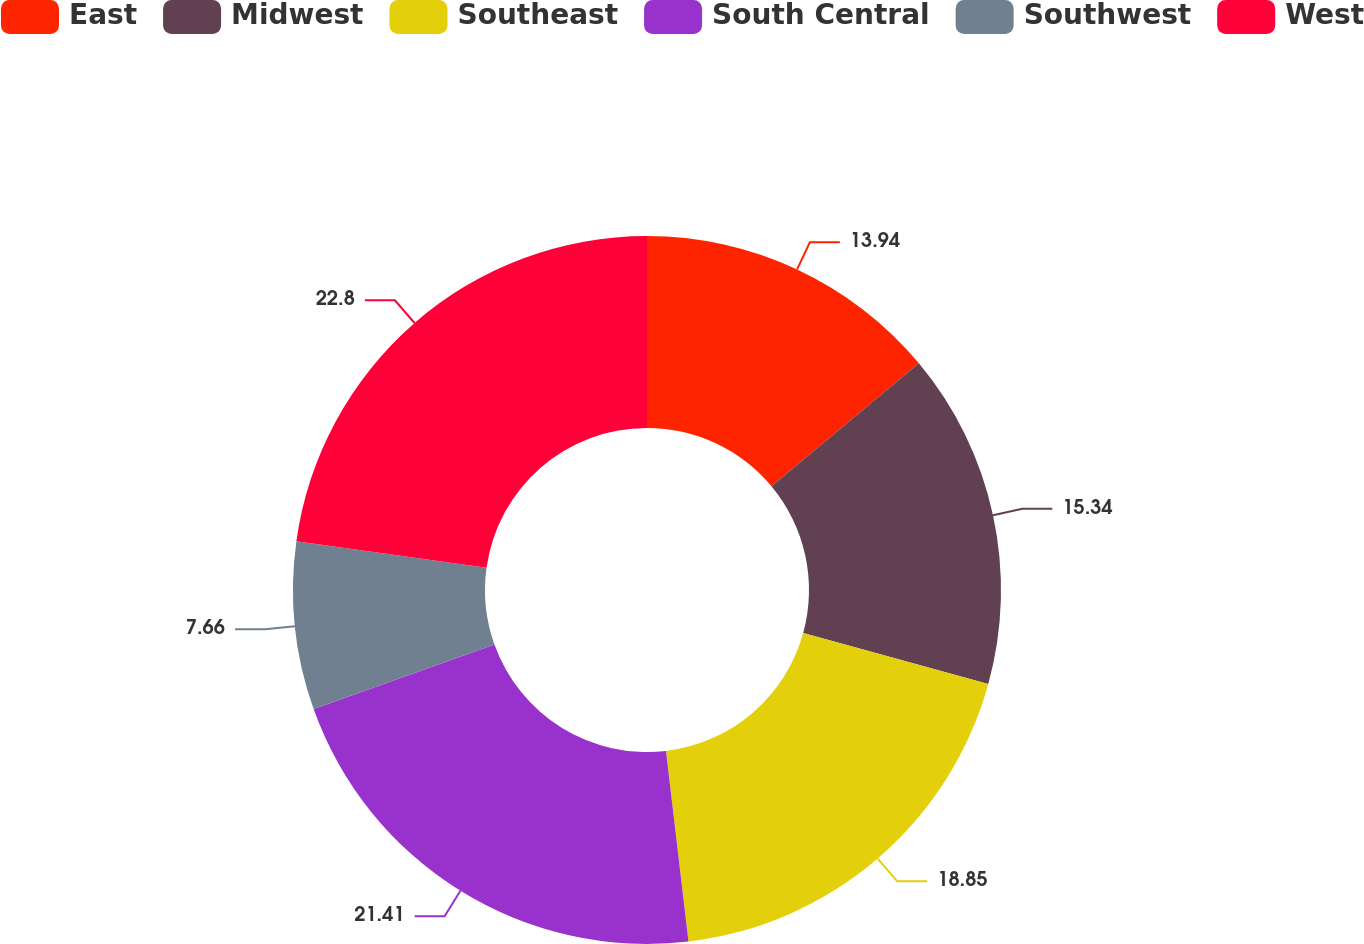Convert chart to OTSL. <chart><loc_0><loc_0><loc_500><loc_500><pie_chart><fcel>East<fcel>Midwest<fcel>Southeast<fcel>South Central<fcel>Southwest<fcel>West<nl><fcel>13.94%<fcel>15.34%<fcel>18.85%<fcel>21.41%<fcel>7.66%<fcel>22.8%<nl></chart> 